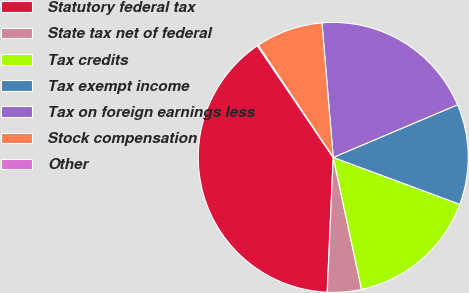Convert chart. <chart><loc_0><loc_0><loc_500><loc_500><pie_chart><fcel>Statutory federal tax<fcel>State tax net of federal<fcel>Tax credits<fcel>Tax exempt income<fcel>Tax on foreign earnings less<fcel>Stock compensation<fcel>Other<nl><fcel>39.79%<fcel>4.08%<fcel>15.99%<fcel>12.02%<fcel>19.95%<fcel>8.05%<fcel>0.12%<nl></chart> 